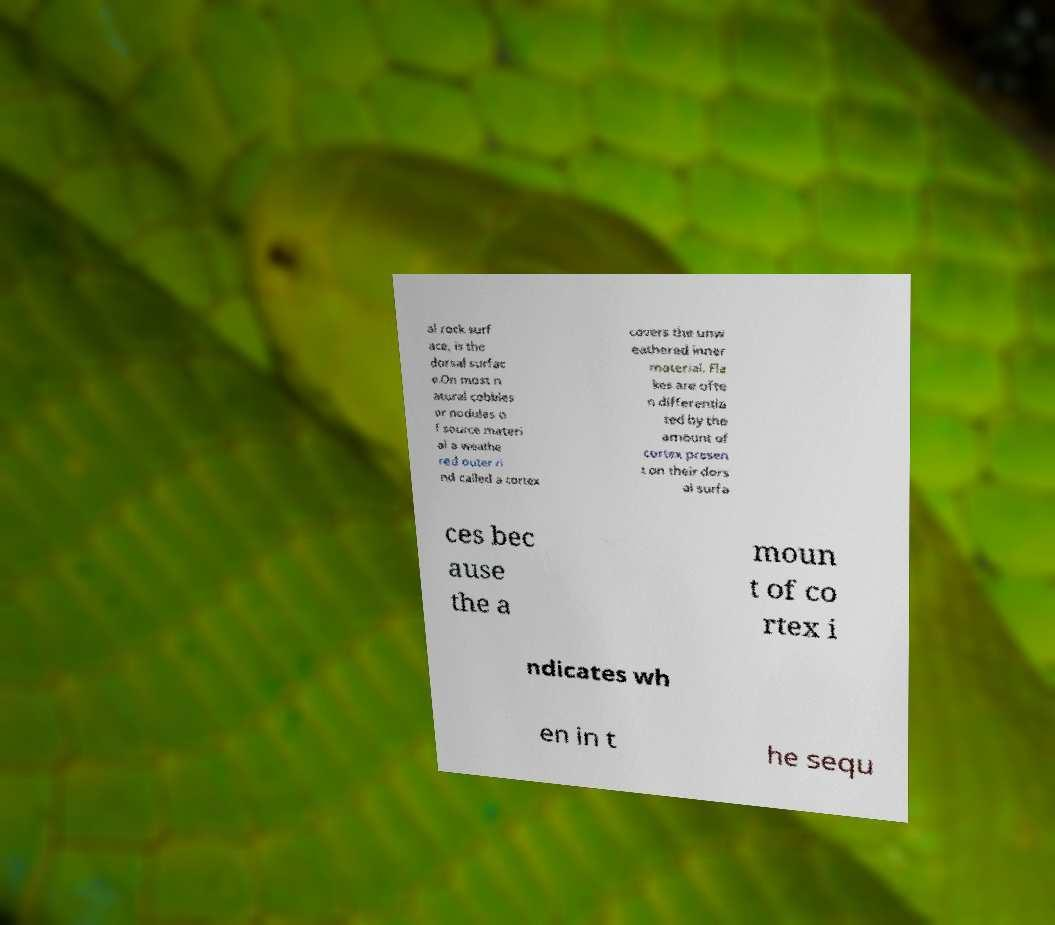Please read and relay the text visible in this image. What does it say? al rock surf ace, is the dorsal surfac e.On most n atural cobbles or nodules o f source materi al a weathe red outer ri nd called a cortex covers the unw eathered inner material. Fla kes are ofte n differentia ted by the amount of cortex presen t on their dors al surfa ces bec ause the a moun t of co rtex i ndicates wh en in t he sequ 